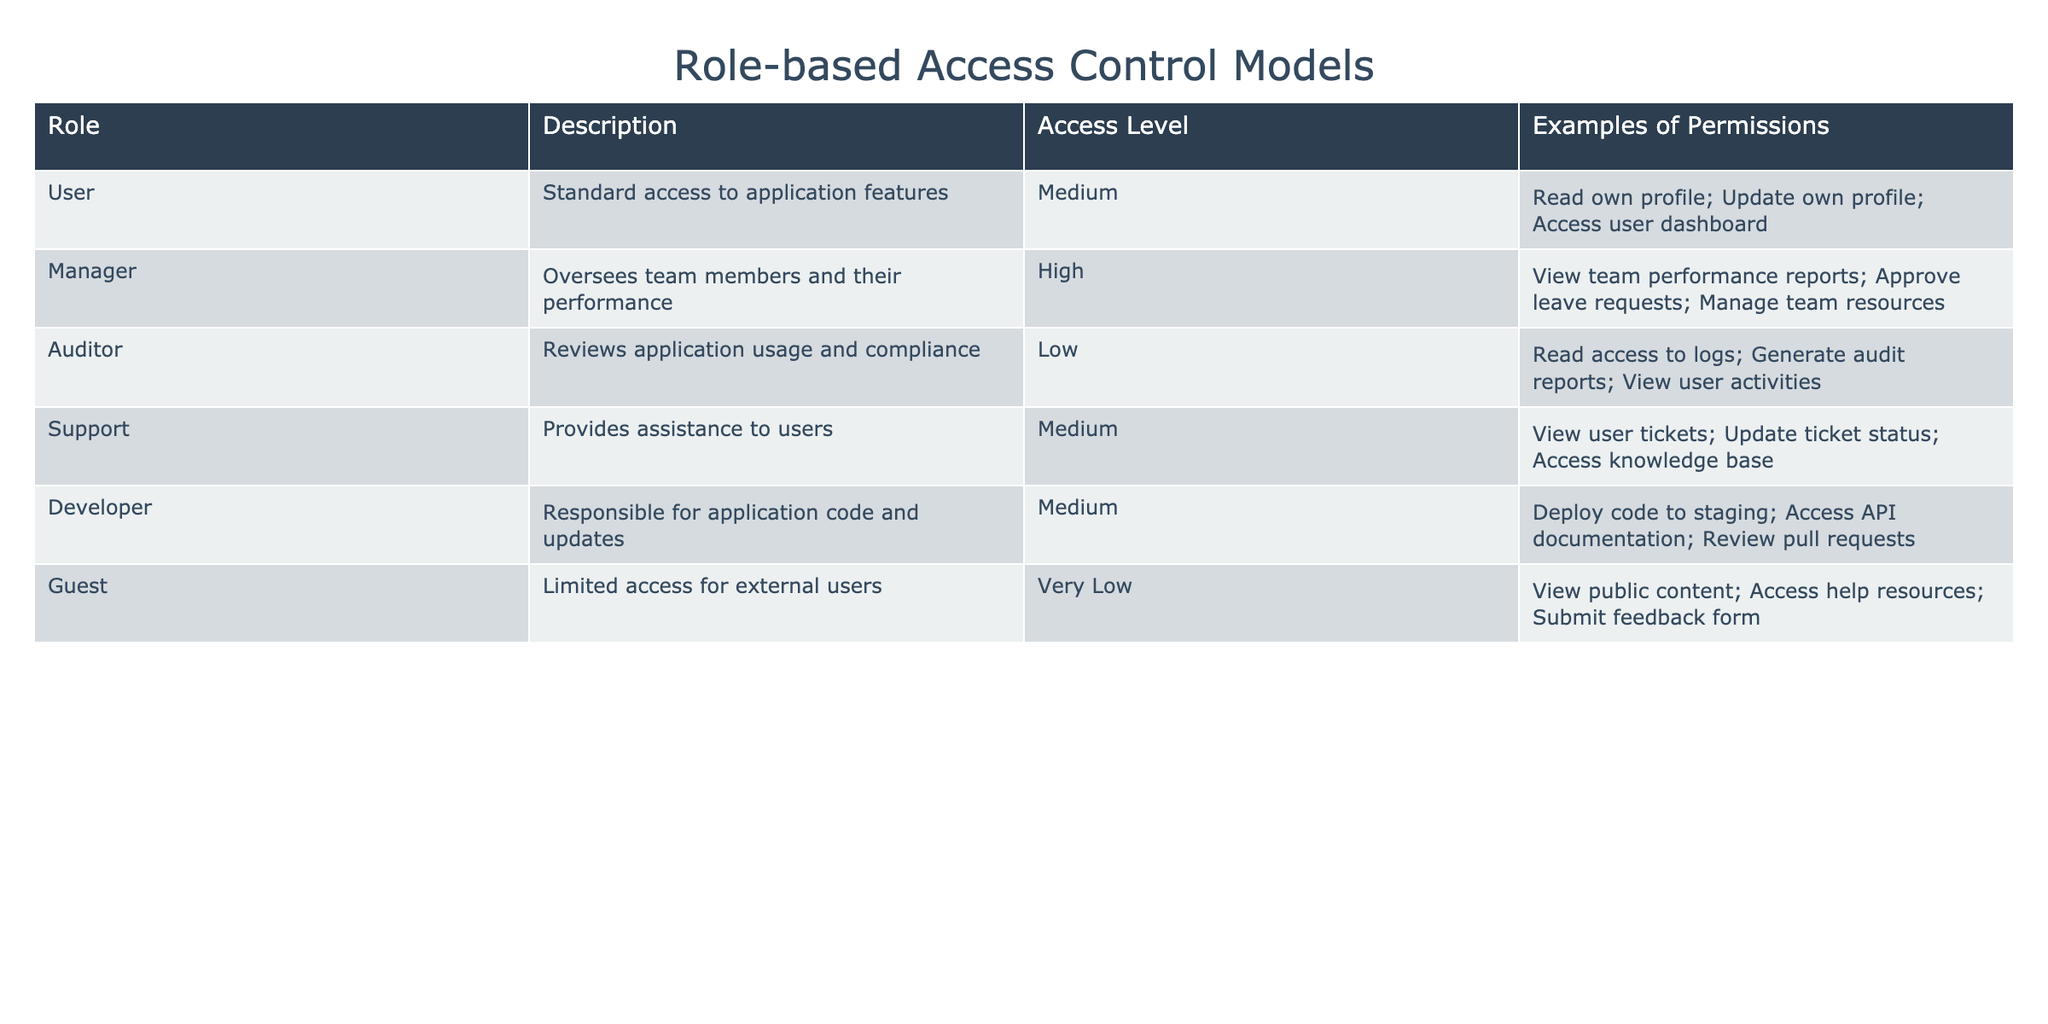What access level does the Auditor role have? The table clearly states that the Auditor role has a Low access level.
Answer: Low Which role has the highest access level? From the table, the Manager role is listed with a High access level, which is the highest compared to all other roles.
Answer: Manager How many roles have a Medium access level? Looking at the table, there are four roles (User, Support, Developer) that have a Medium access level.
Answer: 3 Can a Guest view public content? The table indicates that Guests have the permission to view public content, so the answer is yes.
Answer: Yes Is it true that the User role can update their own profile? The table states that the User role has the permission to update their own profile, so the answer is true.
Answer: True What is the difference in access level between the Manager and Auditor roles? The Manager has a High access level while the Auditor has a Low access level. The difference is High - Low, which means Manager has a higher level than Auditor.
Answer: High If a role has an access level of Very Low, what permission do they have? Referring to the table, roles with a Very Low access level (like Guest) can only perform permissions such as viewing public content, accessing help resources, and submitting feedback forms.
Answer: View public content, access help resources, submit feedback form Which roles can update their profiles? The roles that can update their profiles are User and Support; looking at the permissions shows that both roles have the ability to update information related to their profiles.
Answer: User, Support What is the total number of permissions for the Manager role? The table lists three permissions for the Manager role (view team performance reports, approve leave requests, manage team resources). Thus, the total number of permissions is three.
Answer: 3 